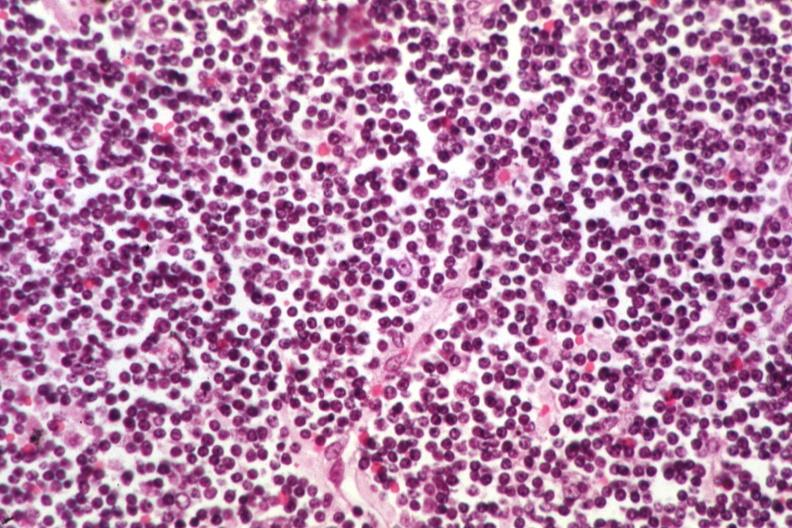what is present?
Answer the question using a single word or phrase. Chronic lymphocytic leukemia 